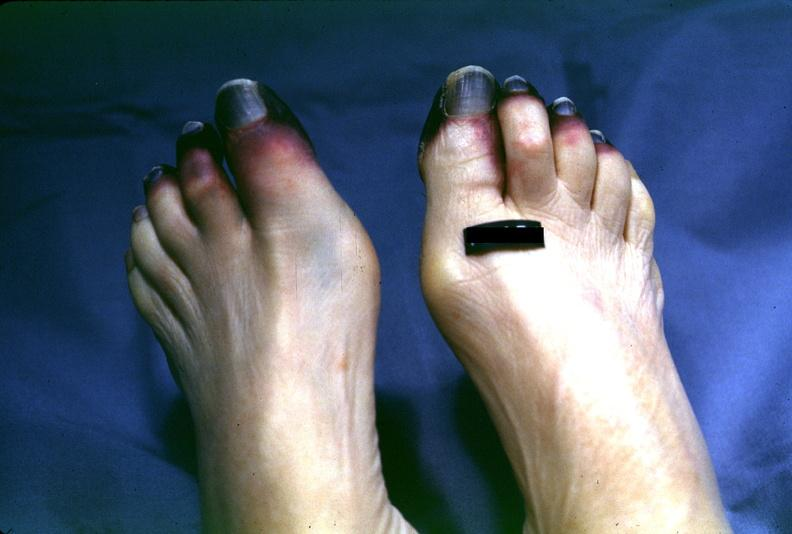what are present?
Answer the question using a single word or phrase. Extremities 